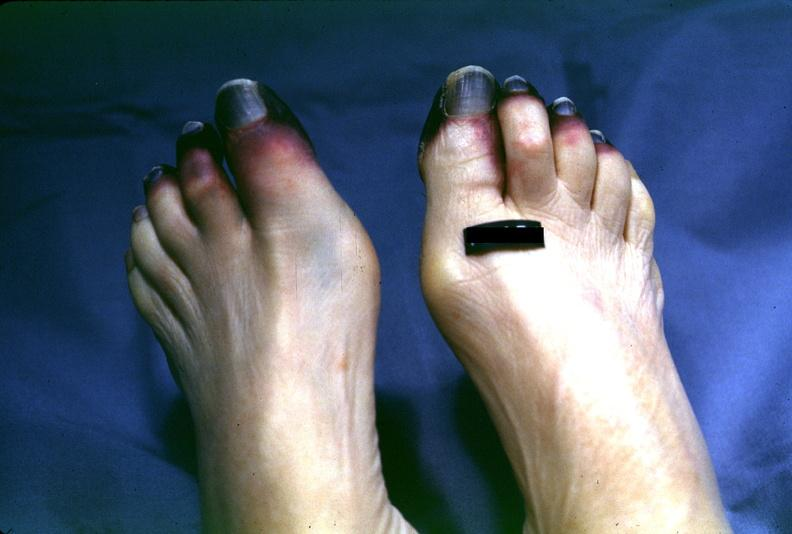what are present?
Answer the question using a single word or phrase. Extremities 